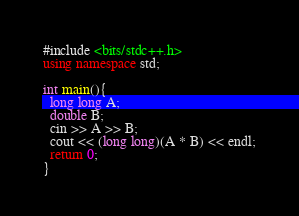<code> <loc_0><loc_0><loc_500><loc_500><_C++_>#include <bits/stdc++.h>
using namespace std;

int main(){
  long long A;
  double B;
  cin >> A >> B;
  cout << (long long)(A * B) << endl;
  return 0;
}
</code> 